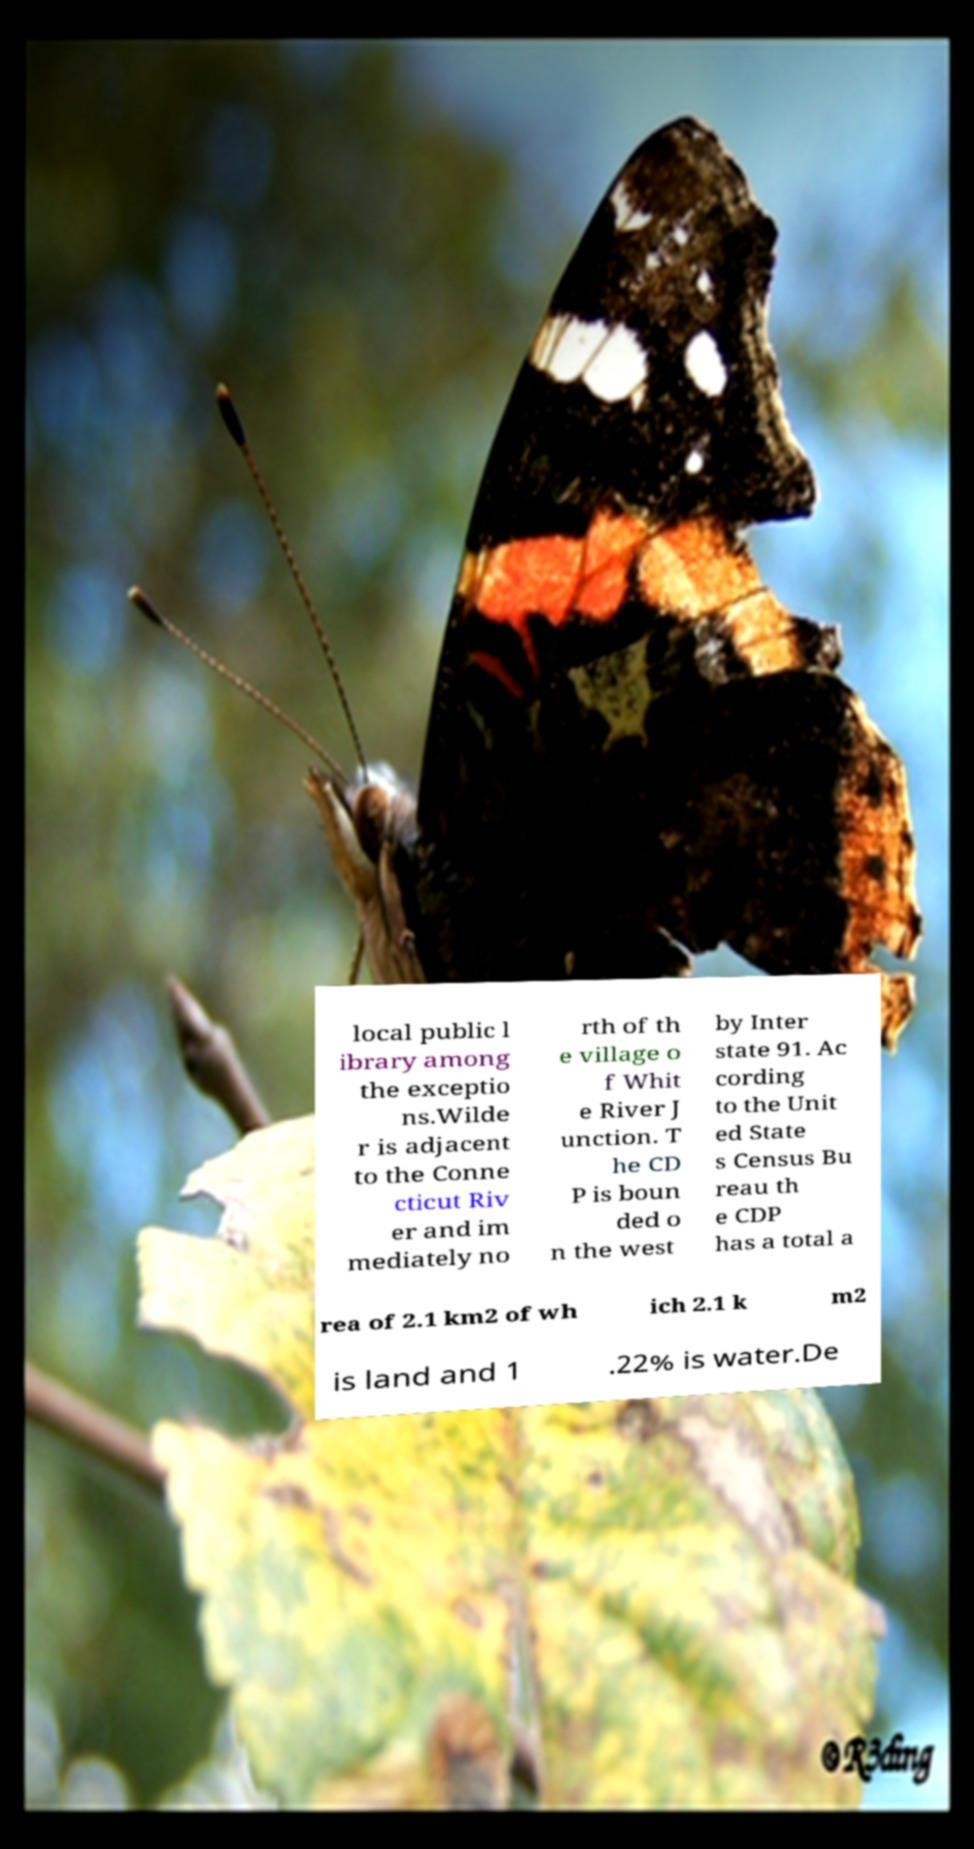Could you extract and type out the text from this image? local public l ibrary among the exceptio ns.Wilde r is adjacent to the Conne cticut Riv er and im mediately no rth of th e village o f Whit e River J unction. T he CD P is boun ded o n the west by Inter state 91. Ac cording to the Unit ed State s Census Bu reau th e CDP has a total a rea of 2.1 km2 of wh ich 2.1 k m2 is land and 1 .22% is water.De 